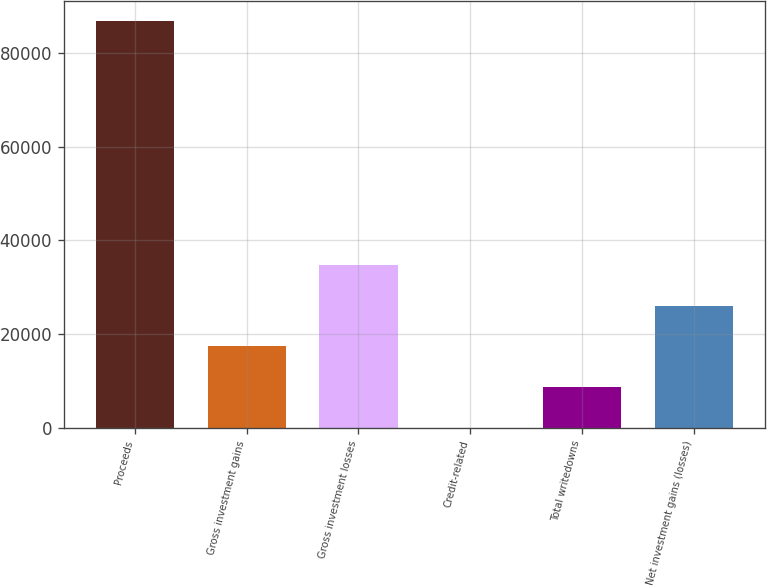<chart> <loc_0><loc_0><loc_500><loc_500><bar_chart><fcel>Proceeds<fcel>Gross investment gains<fcel>Gross investment losses<fcel>Credit-related<fcel>Total writedowns<fcel>Net investment gains (losses)<nl><fcel>86725<fcel>17389.8<fcel>34723.6<fcel>56<fcel>8722.9<fcel>26056.7<nl></chart> 